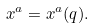Convert formula to latex. <formula><loc_0><loc_0><loc_500><loc_500>x ^ { a } = x ^ { a } ( q ) .</formula> 